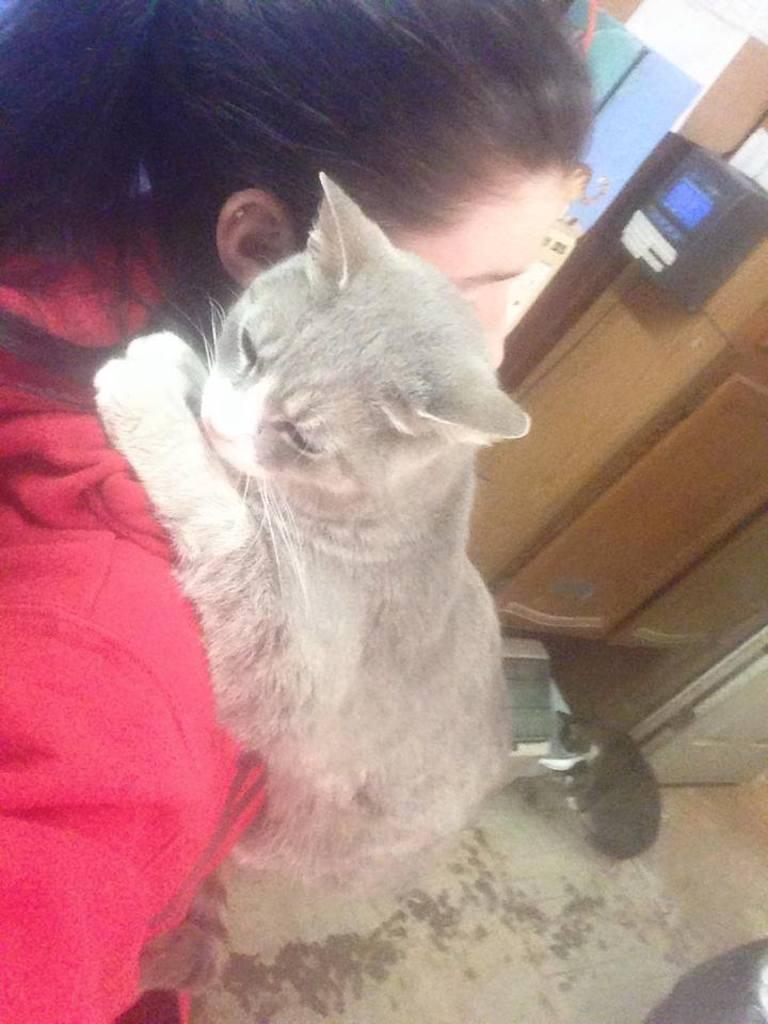Please provide a concise description of this image. In this picture we can see a girl wearing a red sweater carrying a cat on her shoulder. There is also another cat on the ground. 